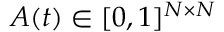<formula> <loc_0><loc_0><loc_500><loc_500>A ( t ) \in [ 0 , 1 ] ^ { N \times N }</formula> 